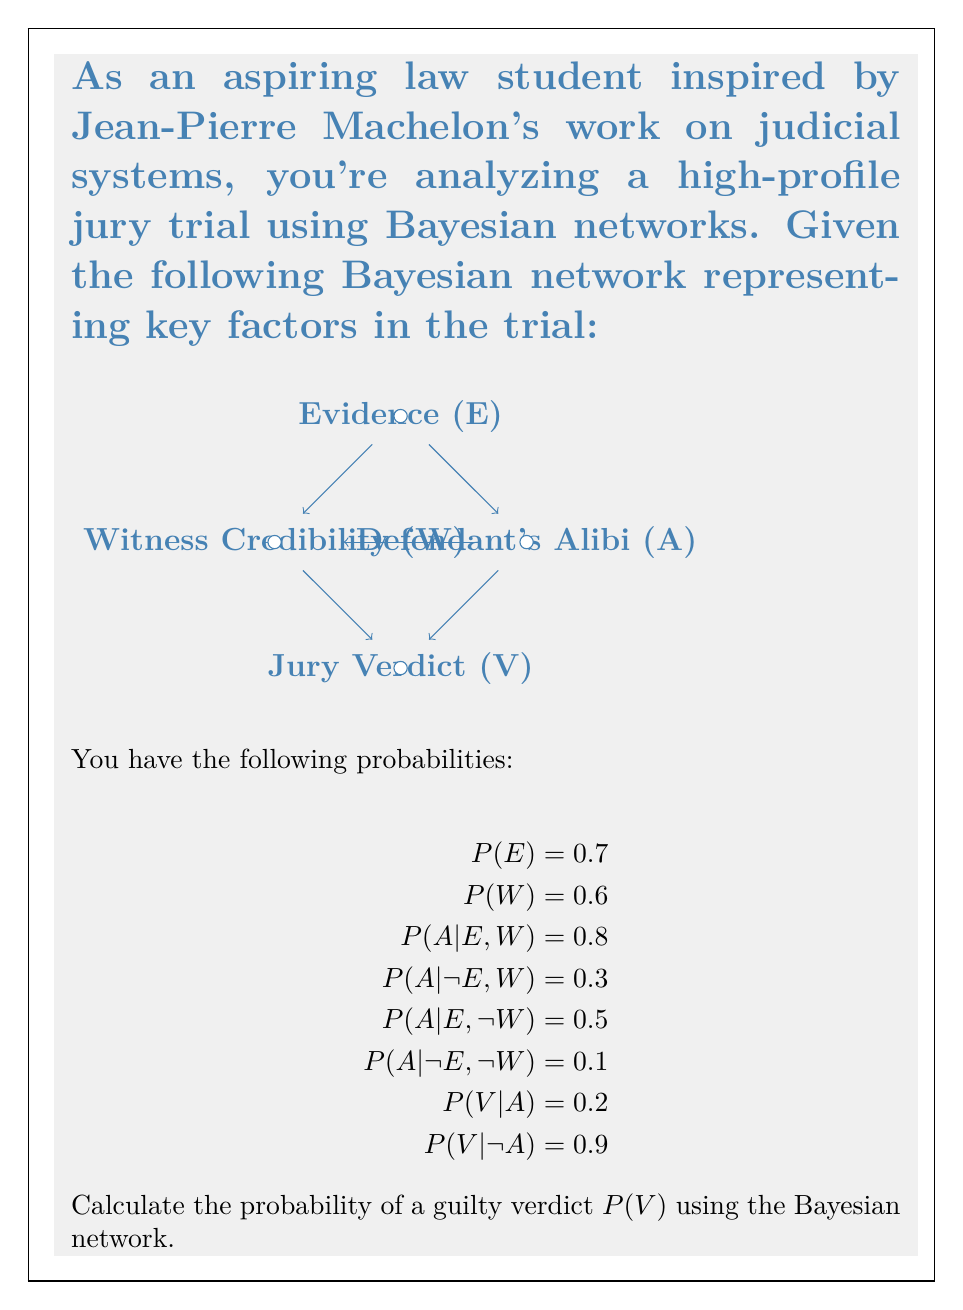What is the answer to this math problem? To solve this problem, we'll use the law of total probability and the chain rule of probability. Let's break it down step by step:

1) First, we need to calculate $P(A)$ using the law of total probability:

   $$P(A) = P(A|E,W)P(E)P(W) + P(A|E,\neg W)P(E)P(\neg W) + P(A|\neg E,W)P(\neg E)P(W) + P(A|\neg E,\neg W)P(\neg E)P(\neg W)$$

2) Substitute the given probabilities:

   $$P(A) = 0.8 \cdot 0.7 \cdot 0.6 + 0.5 \cdot 0.7 \cdot 0.4 + 0.3 \cdot 0.3 \cdot 0.6 + 0.1 \cdot 0.3 \cdot 0.4$$

3) Calculate:

   $$P(A) = 0.336 + 0.14 + 0.054 + 0.012 = 0.542$$

4) Now we can use the law of total probability again to calculate $P(V)$:

   $$P(V) = P(V|A)P(A) + P(V|\neg A)P(\neg A)$$

5) Substitute the values:

   $$P(V) = 0.2 \cdot 0.542 + 0.9 \cdot (1 - 0.542)$$

6) Calculate the final probability:

   $$P(V) = 0.1084 + 0.4122 = 0.5206$$

Therefore, the probability of a guilty verdict is approximately 0.5206 or 52.06%.
Answer: $P(V) \approx 0.5206$ 